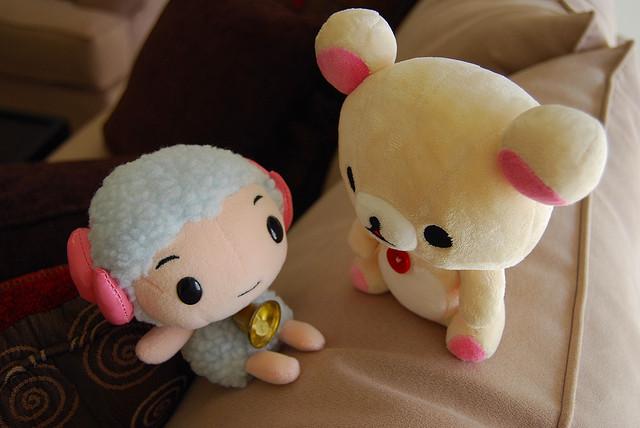What characters are these?
Be succinct. Lamb and bear. Is one of the toys a sheep?
Keep it brief. Yes. What is the bear looking at?
Short answer required. Lamb. Are the stuffed animals eating strawberry cupcakes?
Give a very brief answer. No. What kind of stuffed animal is this?
Be succinct. Bear. How many bears?
Be succinct. 1. What game is depicted by these characters?
Write a very short answer. Pokemon. Would a child like these?
Quick response, please. Yes. Are these stuffed animals?
Give a very brief answer. Yes. Is this a cake?
Keep it brief. No. 